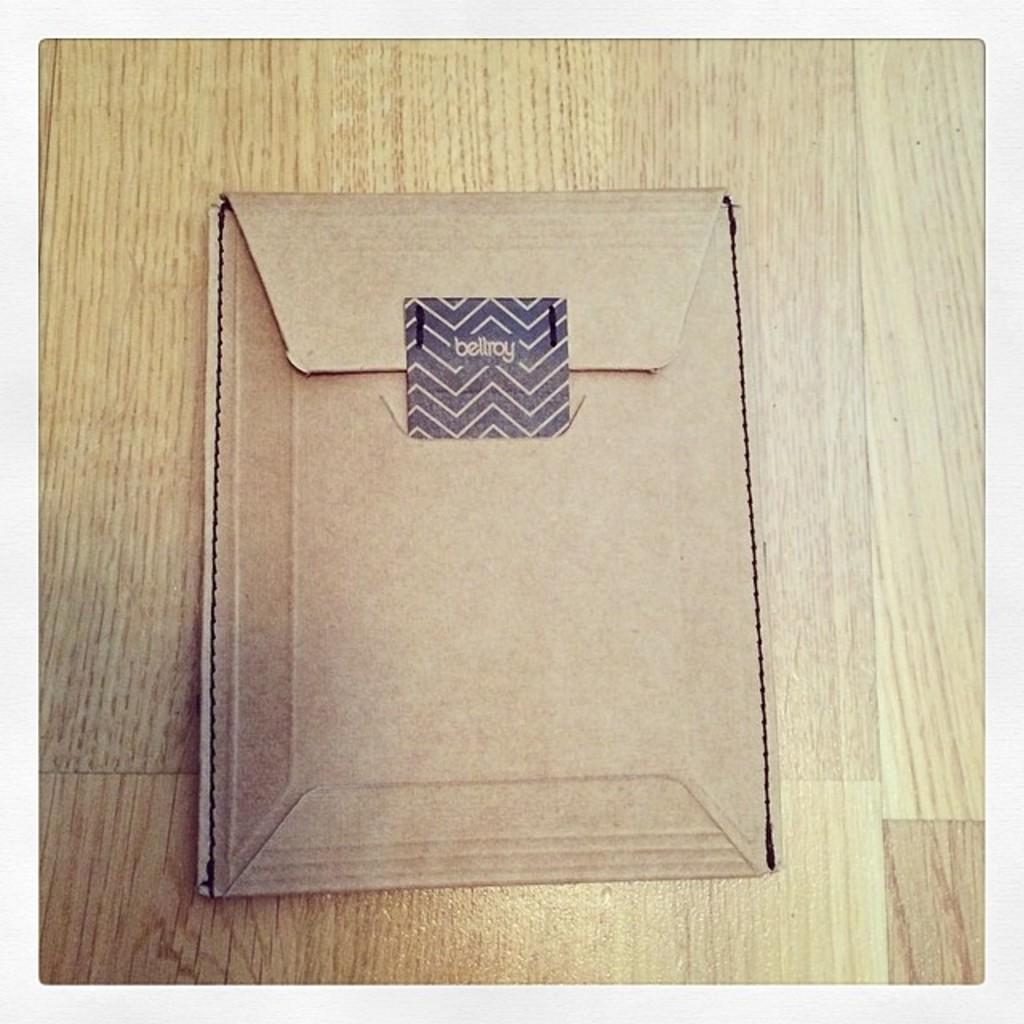Provide a one-sentence caption for the provided image. A card  board manilla folder with a black chevron sticker saying beltroy. 